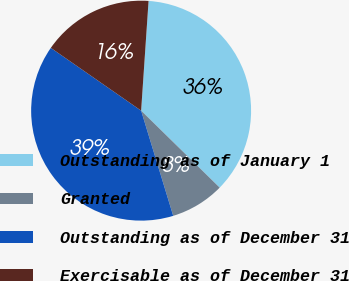Convert chart to OTSL. <chart><loc_0><loc_0><loc_500><loc_500><pie_chart><fcel>Outstanding as of January 1<fcel>Granted<fcel>Outstanding as of December 31<fcel>Exercisable as of December 31<nl><fcel>36.26%<fcel>7.95%<fcel>39.38%<fcel>16.41%<nl></chart> 